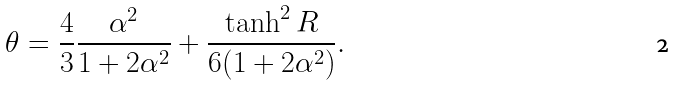<formula> <loc_0><loc_0><loc_500><loc_500>\theta = \frac { 4 } { 3 } \frac { \alpha ^ { 2 } } { 1 + 2 \alpha ^ { 2 } } + \frac { \tanh ^ { 2 } R } { 6 ( 1 + 2 \alpha ^ { 2 } ) } .</formula> 